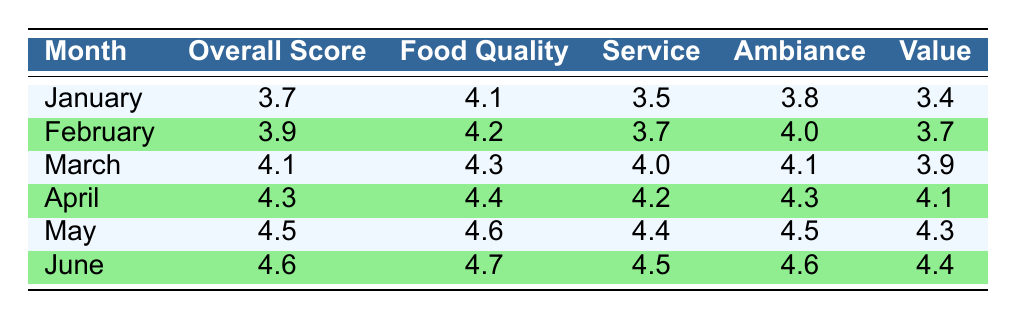What was the overall score in March? According to the table, the overall score for March is listed directly under the "Overall Score" column for that month. The value found is 4.1.
Answer: 4.1 What is the food quality score for June? The table shows that in June, the food quality score is directly recorded under the "Food Quality" column. The score is 4.7.
Answer: 4.7 Which month had the highest ambiance score? By comparing the ambiance scores in the table, April has an ambiance score of 4.3, and June has the highest with a score of 4.6. Therefore, June had the highest ambiance score.
Answer: June What is the average overall score from January to June? To calculate the average overall score, we sum up the overall scores from the table: 3.7 + 3.9 + 4.1 + 4.3 + 4.5 + 4.6 = 25.1. Then, we divide by the number of months (6) which gives us an average of approximately 4.18.
Answer: 4.18 Is the food quality score consistently above 4.0 from March to June? We examine the food quality scores from March (4.3), April (4.4), May (4.6), and June (4.7). All these scores exceed 4.0, confirming that food quality was consistently above 4.0 during this period.
Answer: Yes Which month had the lowest value score? The value scores are: January (3.4), February (3.7), March (3.9), April (4.1), May (4.3), and June (4.4). The lowest score is in January, which is 3.4.
Answer: January What is the difference between the highest and lowest food quality scores? The highest food quality score is in June (4.7), and the lowest is in January (4.1). Calculating the difference: 4.7 - 4.1 = 0.6.
Answer: 0.6 Did the overall score increase every month? Analyzing the overall scores: January (3.7), February (3.9), March (4.1), April (4.3), May (4.5), and June (4.6) shows that the overall score increased each month without any decline.
Answer: Yes What was the average service score for the first three months? The service scores for the first three months are: January (3.5), February (3.7), and March (4.0). Sum these scores: 3.5 + 3.7 + 4.0 = 11.2, and divide by 3 to find the average which is approximately 3.73.
Answer: 3.73 